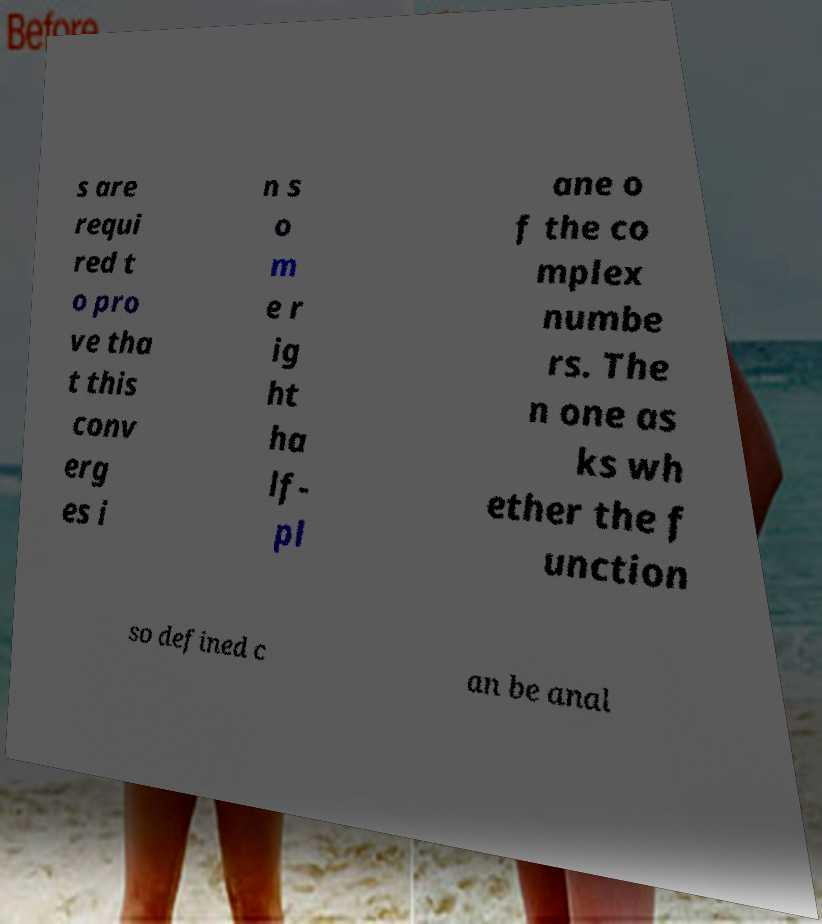What messages or text are displayed in this image? I need them in a readable, typed format. s are requi red t o pro ve tha t this conv erg es i n s o m e r ig ht ha lf- pl ane o f the co mplex numbe rs. The n one as ks wh ether the f unction so defined c an be anal 